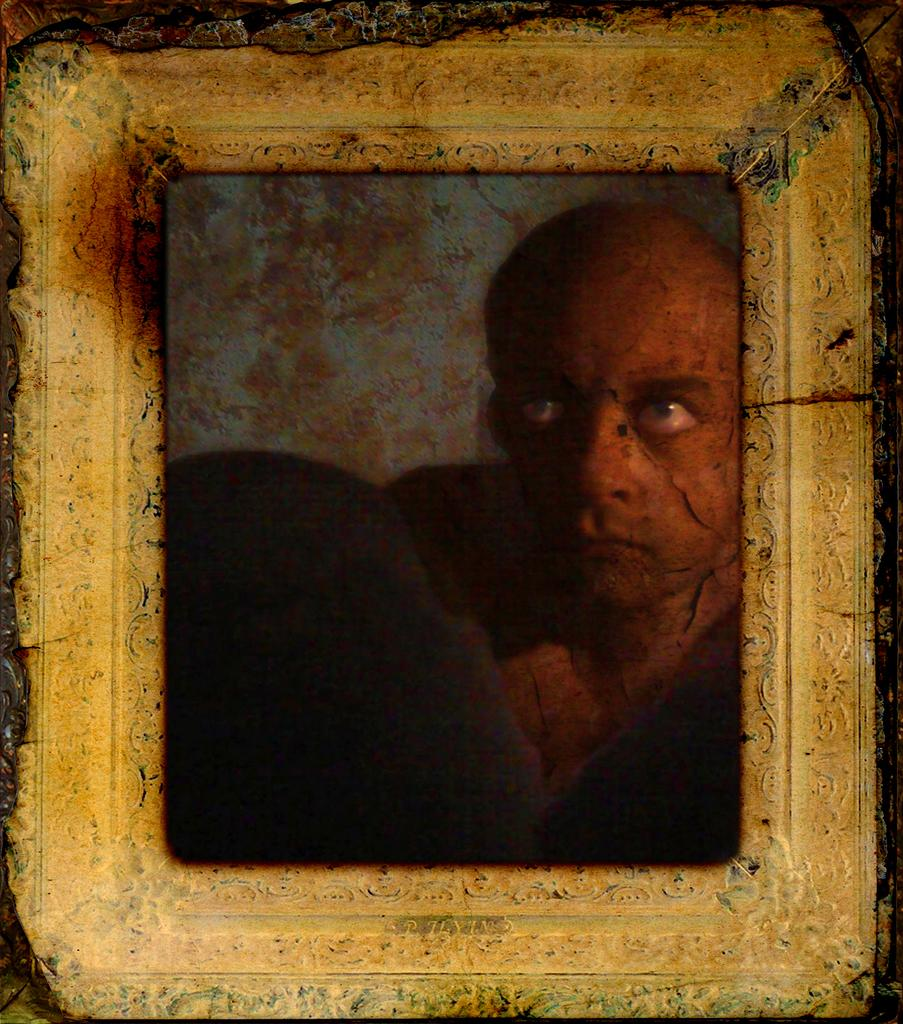What object can be seen in the image that is typically used for displaying photos? There is a photo frame in the image. How many birds can be seen flying inside the photo frame in the image? There are no birds visible inside the photo frame in the image. What type of key is used to unlock the photo frame in the image? There is no key present in the image, as photo frames typically do not require keys for operation. 